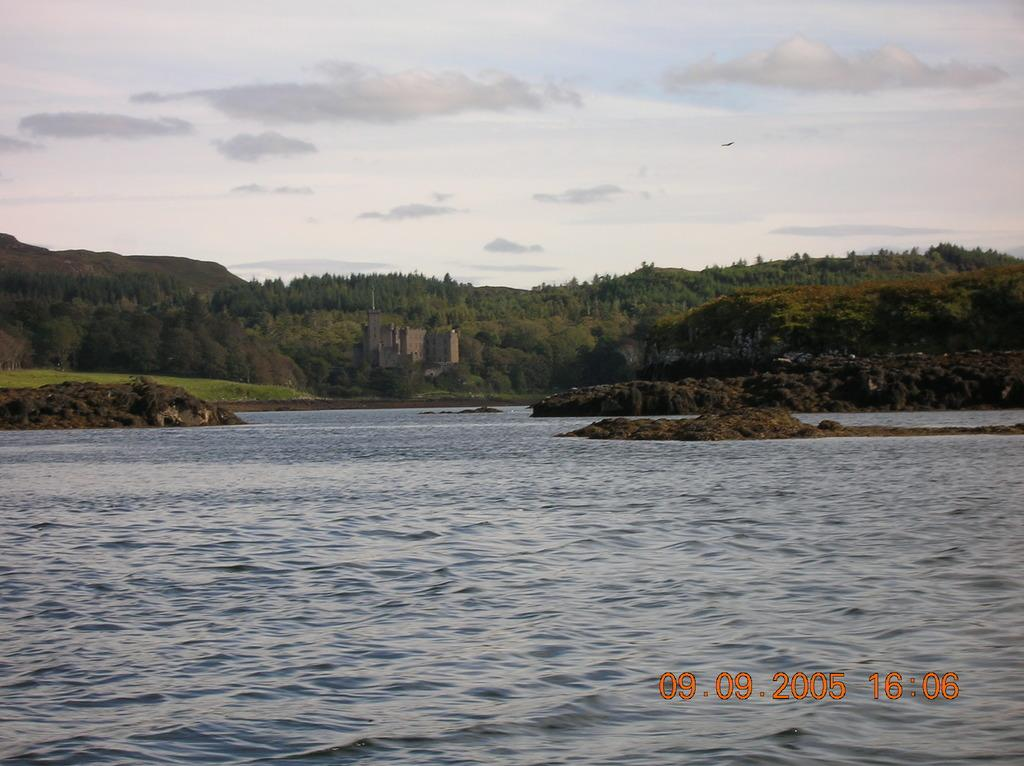What is the primary element visible in the image? There is water in the image. What type of structure can be seen in the image? There is a building in the image. What type of vegetation is present in the image? There are trees in the image. What type of terrain is visible in the image? There are hills in the image. What is visible in the sky in the image? The sky is visible in the image, and clouds are present. What type of rake is being used by the brother in the image? There is no brother or rake present in the image. What does the image smell like? The image does not have a smell, as it is a visual representation. 